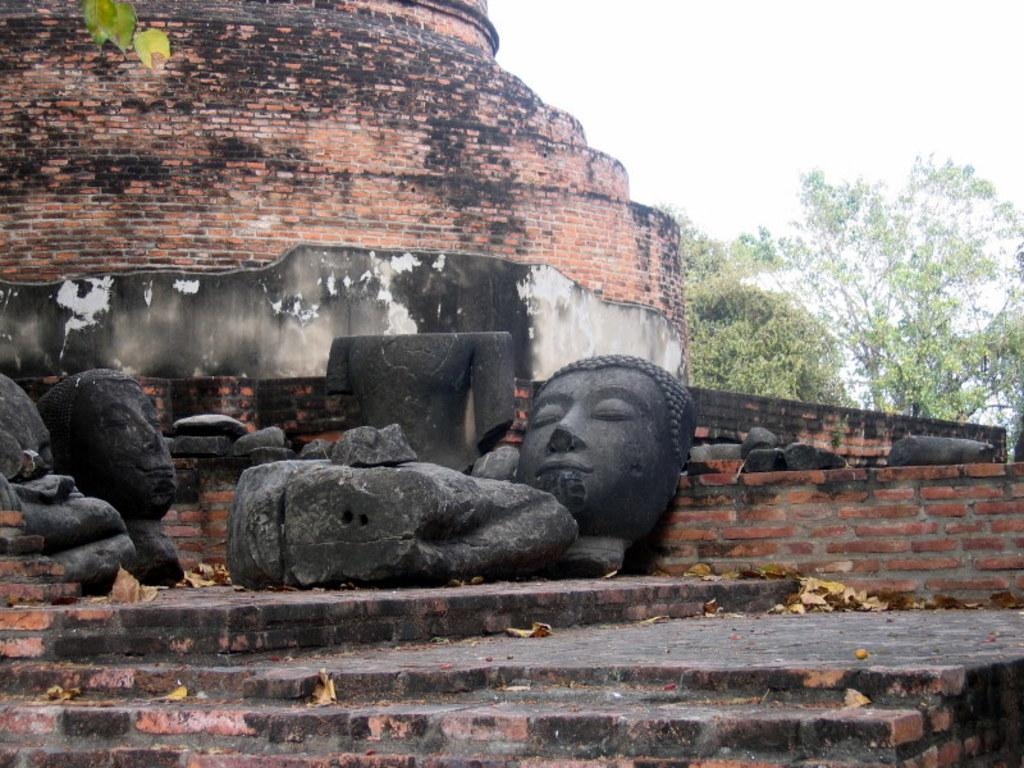What is located in front of the image? There are steps in front in the image. What type of art is present in the image? There are sculptures in the image. What color are the sculptures? The sculptures are black in color. What can be seen in the background of the image? There is a building, trees, and the sky visible in the background of the image. How many spiders are crawling on the sculptures in the image? There are no spiders present in the image; it only features sculptures and steps. What process is being carried out by the workers in the image? There are no workers or any process being carried out in the image. 